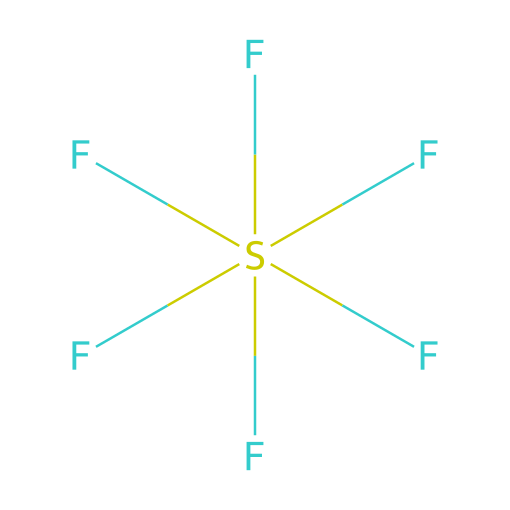What is the molecular formula of this compound? The SMILES representation shows six fluorine (F) atoms bonded to one sulfur (S) atom, indicating the molecular formula is SF6.
Answer: SF6 How many fluorine atoms are present in the structure? By analyzing the chemical structure, there are six fluorine atoms attached to the sulfur atom.
Answer: 6 What type of compound is sulfur hexafluoride? The molecular structure shows that sulfur is surrounded by more than four bonds, which classifies it as a hypervalent compound.
Answer: hypervalent What is the oxidation state of sulfur in this compound? In SF6, sulfur typically has an oxidation state of +6, as it forms six bonds with fluorine atoms, each counted as -1.
Answer: +6 How would you describe the molecular geometry of sulfur hexafluoride? Considering the arrangement of six fluorine atoms around the sulfur atom, the molecular geometry is octahedral due to electron pair repulsion.
Answer: octahedral What is the primary use of sulfur hexafluoride in industry? Sulfur hexafluoride is primarily used as an insulating gas in electrical equipment due to its excellent dielectric properties.
Answer: insulating gas Is sulfur hexafluoride polar or nonpolar? The symmetric arrangement of fluorine atoms around the sulfur creates a nonpolar molecular structure.
Answer: nonpolar 